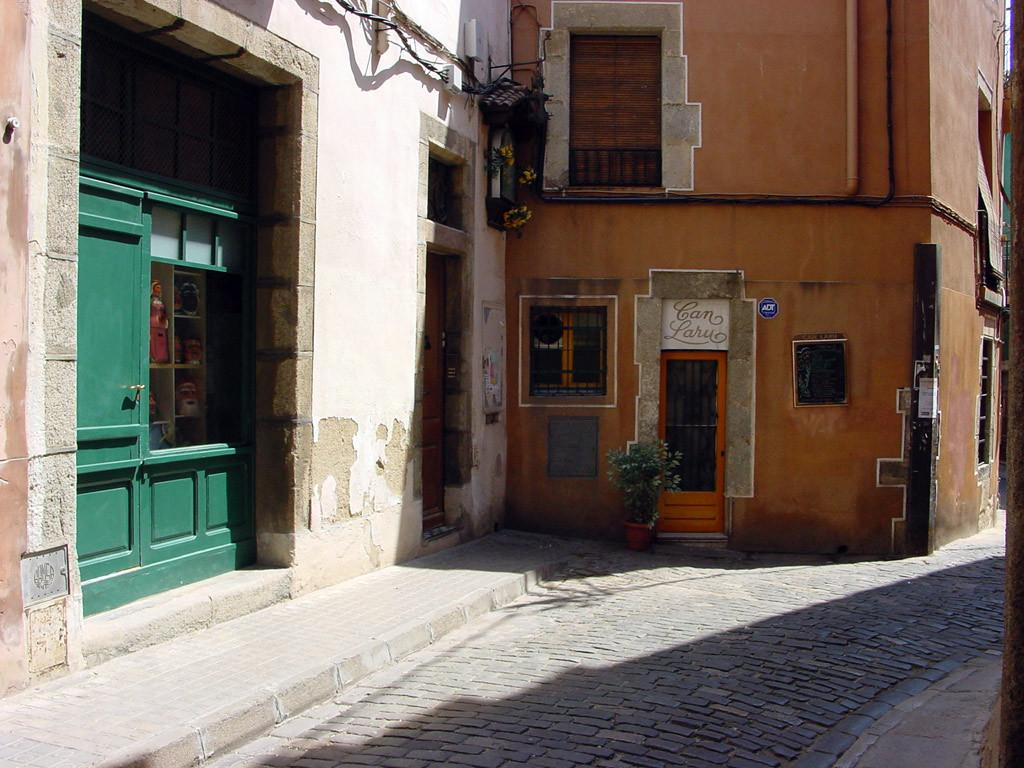What type of structures are visible in the image? There are buildings in the image. What features can be seen on the buildings? The buildings have windows and doors. What is present near the buildings? There is a sign board with text and plants in the image. What type of items are placed in racks in the image? There are dolls placed in racks in the image. What can be used for walking or moving around in the image? There is a pathway in the image. Reasoning: Let' Let's think step by step in order to produce the conversation. We start by identifying the main subject in the image, which is the buildings. Then, we expand the conversation to include other details about the buildings, such as their features and surroundings. We also mention the presence of dolls in racks and a pathway, which are additional elements in the image. Each question is designed to elicit a specific detail about the image that is known from the provided facts. Absurd Question/Answer: What type of feast is being prepared in the image? There is no indication of a feast being prepared in the image. How does the growth of the plants affect the appearance of the buildings in the image? The provided facts do not mention the growth of the plants or their impact on the appearance of the buildings. How does the growth of the plants affect the appearance of the buildings in the image? The provided facts do not mention the growth of the plants or their impact on the appearance of the buildings. 